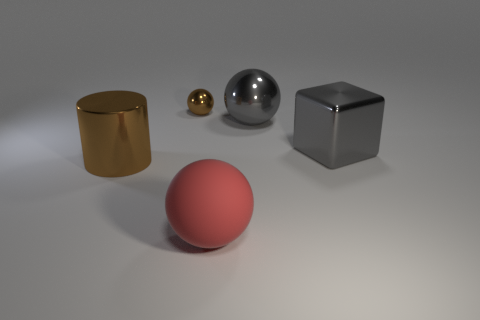Add 4 big metal cylinders. How many objects exist? 9 Subtract all spheres. How many objects are left? 2 Subtract 1 red spheres. How many objects are left? 4 Subtract all green rubber cubes. Subtract all metal objects. How many objects are left? 1 Add 4 blocks. How many blocks are left? 5 Add 4 tiny cyan metal things. How many tiny cyan metal things exist? 4 